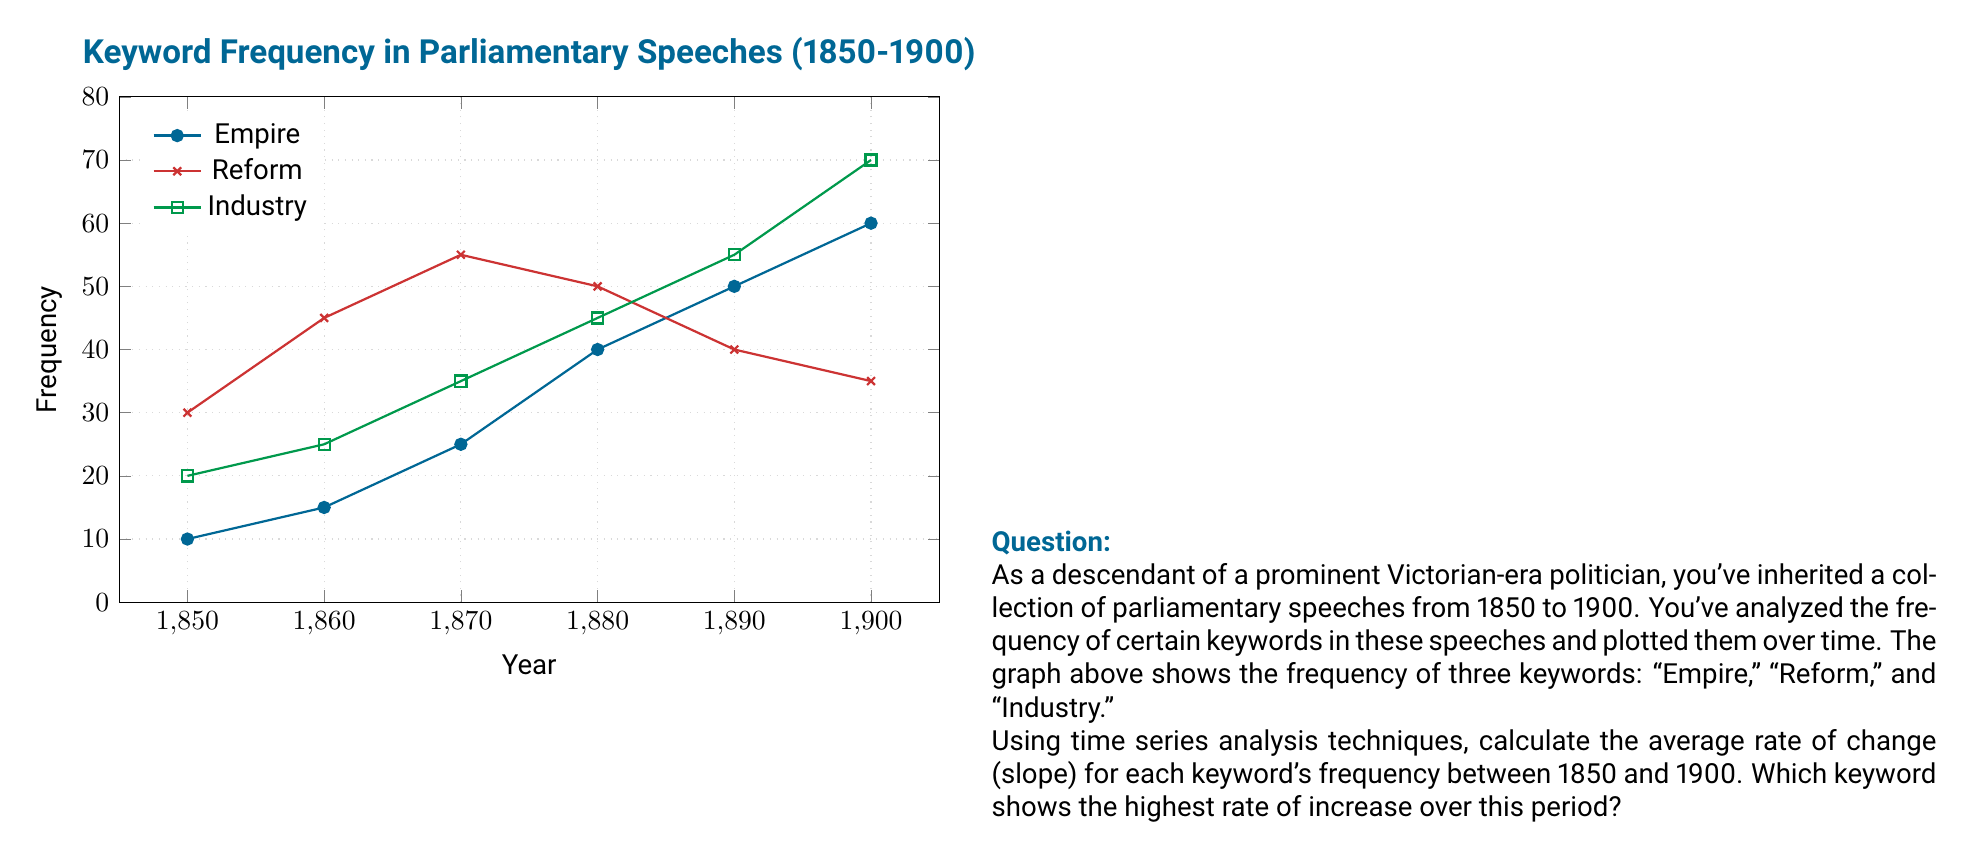What is the answer to this math problem? To solve this problem, we need to calculate the average rate of change (slope) for each keyword over the given time period. The slope formula is:

$$ \text{Slope} = \frac{\text{Change in } y}{\text{Change in } x} = \frac{y_2 - y_1}{x_2 - x_1} $$

where $(x_1, y_1)$ is the initial point and $(x_2, y_2)$ is the final point.

Let's calculate for each keyword:

1. Empire:
   Initial point: (1850, 10)
   Final point: (1900, 60)
   $$ \text{Slope}_{\text{Empire}} = \frac{60 - 10}{1900 - 1850} = \frac{50}{50} = 1 $$

2. Reform:
   Initial point: (1850, 30)
   Final point: (1900, 35)
   $$ \text{Slope}_{\text{Reform}} = \frac{35 - 30}{1900 - 1850} = \frac{5}{50} = 0.1 $$

3. Industry:
   Initial point: (1850, 20)
   Final point: (1900, 70)
   $$ \text{Slope}_{\text{Industry}} = \frac{70 - 20}{1900 - 1850} = \frac{50}{50} = 1 $$

Comparing the slopes:
Empire: 1
Reform: 0.1
Industry: 1

Both Empire and Industry have the highest rate of increase with a slope of 1, while Reform has the lowest rate of increase with a slope of 0.1.
Answer: Empire and Industry (tied at 1) 